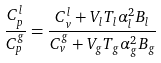<formula> <loc_0><loc_0><loc_500><loc_500>\frac { C _ { p } ^ { l } } { C _ { p } ^ { g } } = \frac { C _ { v } ^ { l } + V _ { l } T _ { l } \alpha _ { l } ^ { 2 } B _ { l } } { C _ { v } ^ { g } + V _ { g } T _ { g } \alpha _ { g } ^ { 2 } B _ { g } }</formula> 